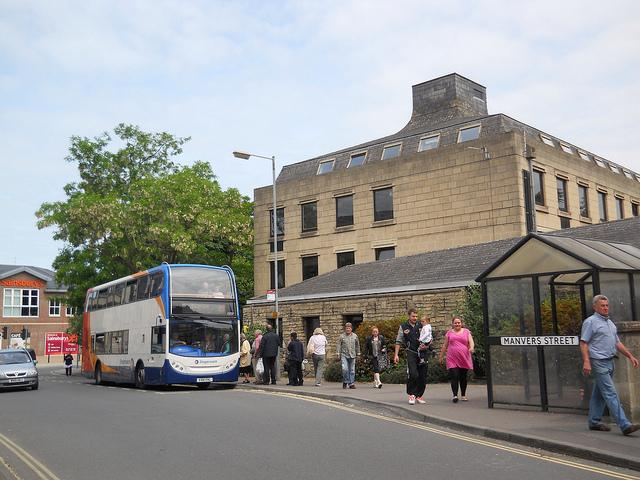When was the first bus stop installed?

Choices:
A) 1820s
B) 1840s
C) 1860s
D) 1850s 1820s 